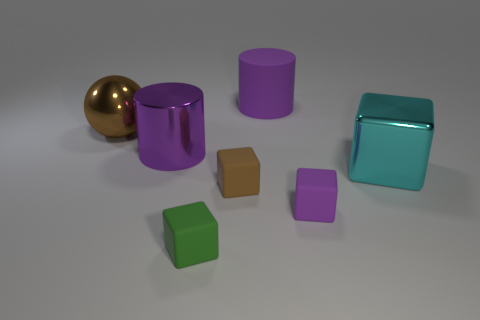Add 1 big cyan cubes. How many objects exist? 8 Subtract all cylinders. How many objects are left? 5 Subtract all cyan cubes. Subtract all purple matte spheres. How many objects are left? 6 Add 4 large metallic balls. How many large metallic balls are left? 5 Add 2 matte cylinders. How many matte cylinders exist? 3 Subtract 1 brown balls. How many objects are left? 6 